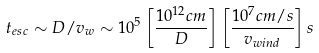<formula> <loc_0><loc_0><loc_500><loc_500>t _ { e s c } \sim D / v _ { w } \sim 1 0 ^ { 5 } \left [ \frac { 1 0 ^ { 1 2 } c m } { D } \right ] \left [ \frac { 1 0 ^ { 7 } c m / s } { v _ { w i n d } } \right ] s</formula> 